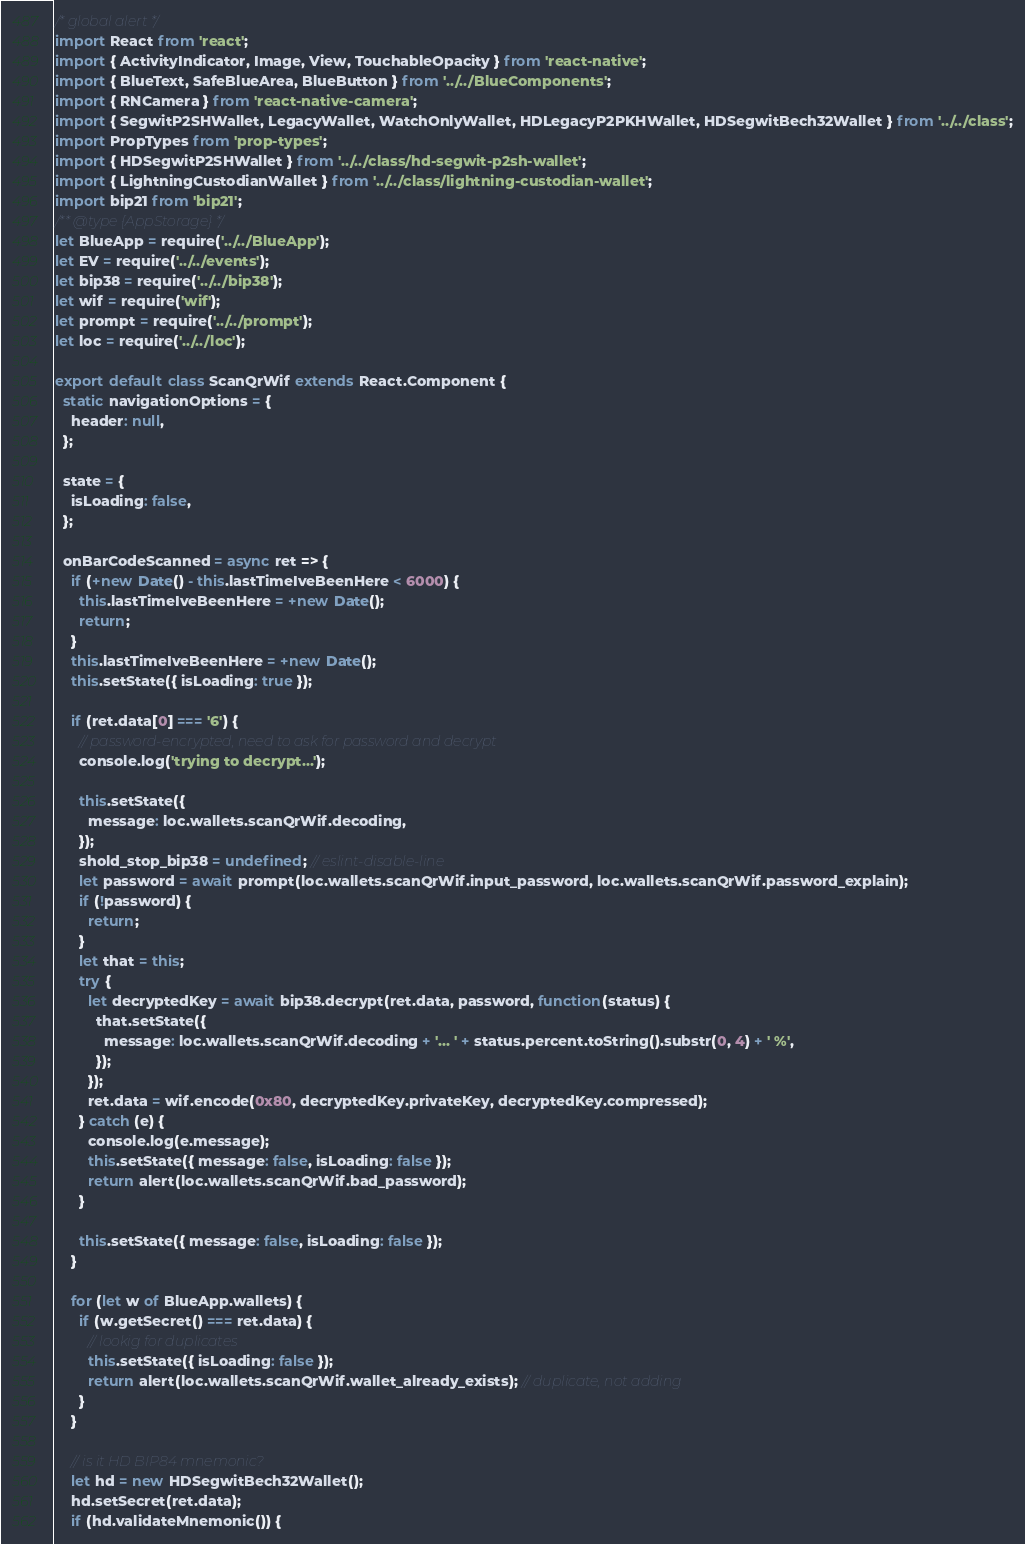Convert code to text. <code><loc_0><loc_0><loc_500><loc_500><_JavaScript_>/* global alert */
import React from 'react';
import { ActivityIndicator, Image, View, TouchableOpacity } from 'react-native';
import { BlueText, SafeBlueArea, BlueButton } from '../../BlueComponents';
import { RNCamera } from 'react-native-camera';
import { SegwitP2SHWallet, LegacyWallet, WatchOnlyWallet, HDLegacyP2PKHWallet, HDSegwitBech32Wallet } from '../../class';
import PropTypes from 'prop-types';
import { HDSegwitP2SHWallet } from '../../class/hd-segwit-p2sh-wallet';
import { LightningCustodianWallet } from '../../class/lightning-custodian-wallet';
import bip21 from 'bip21';
/** @type {AppStorage} */
let BlueApp = require('../../BlueApp');
let EV = require('../../events');
let bip38 = require('../../bip38');
let wif = require('wif');
let prompt = require('../../prompt');
let loc = require('../../loc');

export default class ScanQrWif extends React.Component {
  static navigationOptions = {
    header: null,
  };

  state = {
    isLoading: false,
  };

  onBarCodeScanned = async ret => {
    if (+new Date() - this.lastTimeIveBeenHere < 6000) {
      this.lastTimeIveBeenHere = +new Date();
      return;
    }
    this.lastTimeIveBeenHere = +new Date();
    this.setState({ isLoading: true });

    if (ret.data[0] === '6') {
      // password-encrypted, need to ask for password and decrypt
      console.log('trying to decrypt...');

      this.setState({
        message: loc.wallets.scanQrWif.decoding,
      });
      shold_stop_bip38 = undefined; // eslint-disable-line
      let password = await prompt(loc.wallets.scanQrWif.input_password, loc.wallets.scanQrWif.password_explain);
      if (!password) {
        return;
      }
      let that = this;
      try {
        let decryptedKey = await bip38.decrypt(ret.data, password, function(status) {
          that.setState({
            message: loc.wallets.scanQrWif.decoding + '... ' + status.percent.toString().substr(0, 4) + ' %',
          });
        });
        ret.data = wif.encode(0x80, decryptedKey.privateKey, decryptedKey.compressed);
      } catch (e) {
        console.log(e.message);
        this.setState({ message: false, isLoading: false });
        return alert(loc.wallets.scanQrWif.bad_password);
      }

      this.setState({ message: false, isLoading: false });
    }

    for (let w of BlueApp.wallets) {
      if (w.getSecret() === ret.data) {
        // lookig for duplicates
        this.setState({ isLoading: false });
        return alert(loc.wallets.scanQrWif.wallet_already_exists); // duplicate, not adding
      }
    }

    // is it HD BIP84 mnemonic?
    let hd = new HDSegwitBech32Wallet();
    hd.setSecret(ret.data);
    if (hd.validateMnemonic()) {</code> 